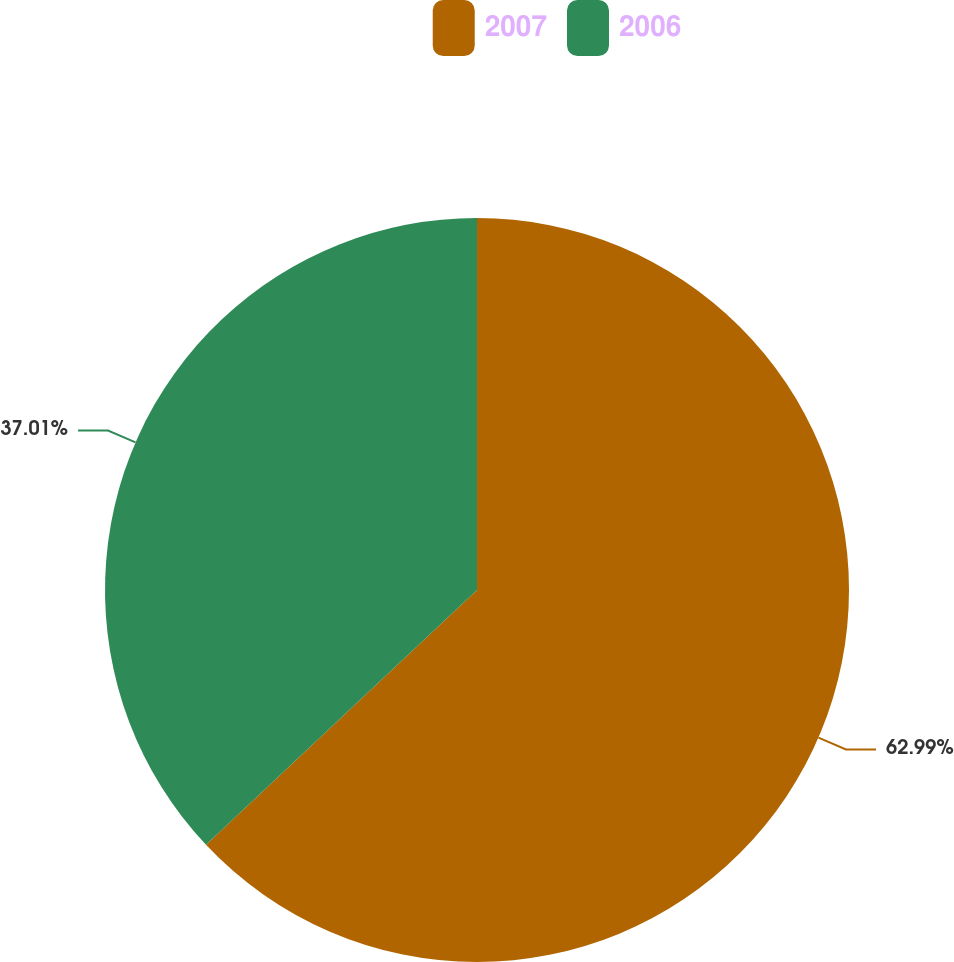<chart> <loc_0><loc_0><loc_500><loc_500><pie_chart><fcel>2007<fcel>2006<nl><fcel>62.99%<fcel>37.01%<nl></chart> 